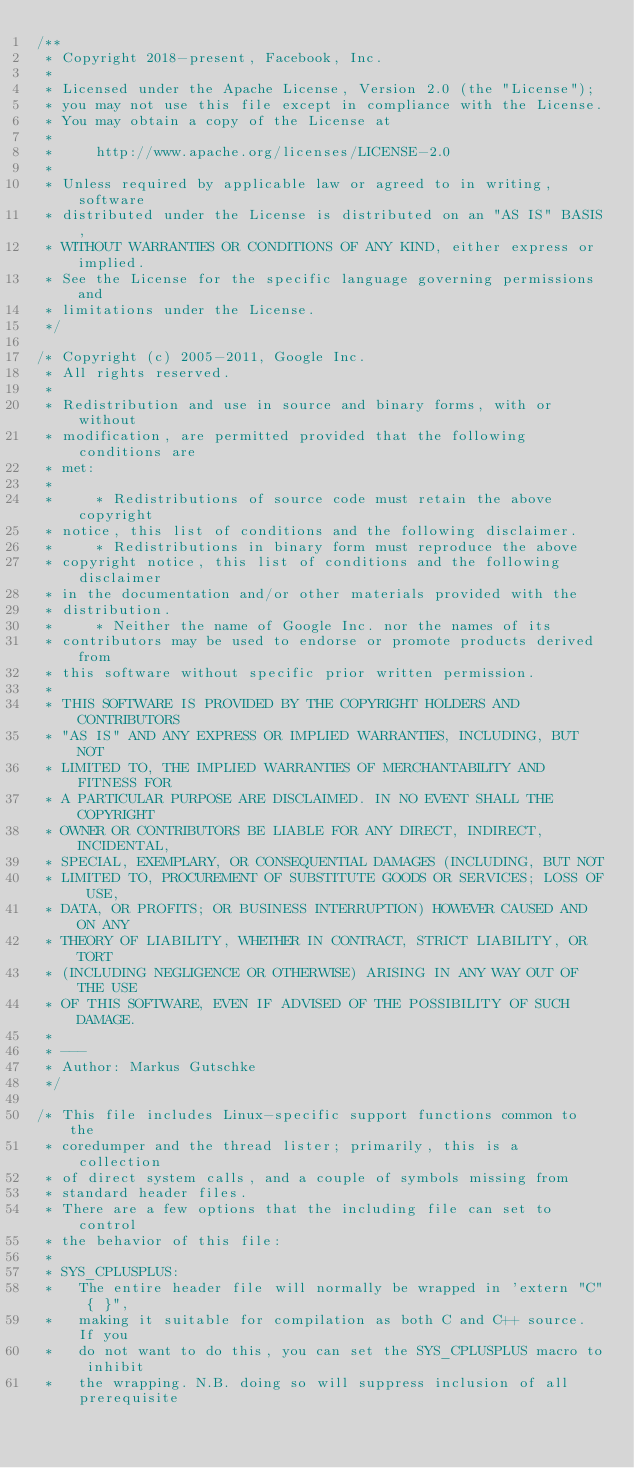Convert code to text. <code><loc_0><loc_0><loc_500><loc_500><_C_>/**
 * Copyright 2018-present, Facebook, Inc.
 *
 * Licensed under the Apache License, Version 2.0 (the "License");
 * you may not use this file except in compliance with the License.
 * You may obtain a copy of the License at
 *
 *     http://www.apache.org/licenses/LICENSE-2.0
 *
 * Unless required by applicable law or agreed to in writing, software
 * distributed under the License is distributed on an "AS IS" BASIS,
 * WITHOUT WARRANTIES OR CONDITIONS OF ANY KIND, either express or implied.
 * See the License for the specific language governing permissions and
 * limitations under the License.
 */

/* Copyright (c) 2005-2011, Google Inc.
 * All rights reserved.
 *
 * Redistribution and use in source and binary forms, with or without
 * modification, are permitted provided that the following conditions are
 * met:
 *
 *     * Redistributions of source code must retain the above copyright
 * notice, this list of conditions and the following disclaimer.
 *     * Redistributions in binary form must reproduce the above
 * copyright notice, this list of conditions and the following disclaimer
 * in the documentation and/or other materials provided with the
 * distribution.
 *     * Neither the name of Google Inc. nor the names of its
 * contributors may be used to endorse or promote products derived from
 * this software without specific prior written permission.
 *
 * THIS SOFTWARE IS PROVIDED BY THE COPYRIGHT HOLDERS AND CONTRIBUTORS
 * "AS IS" AND ANY EXPRESS OR IMPLIED WARRANTIES, INCLUDING, BUT NOT
 * LIMITED TO, THE IMPLIED WARRANTIES OF MERCHANTABILITY AND FITNESS FOR
 * A PARTICULAR PURPOSE ARE DISCLAIMED. IN NO EVENT SHALL THE COPYRIGHT
 * OWNER OR CONTRIBUTORS BE LIABLE FOR ANY DIRECT, INDIRECT, INCIDENTAL,
 * SPECIAL, EXEMPLARY, OR CONSEQUENTIAL DAMAGES (INCLUDING, BUT NOT
 * LIMITED TO, PROCUREMENT OF SUBSTITUTE GOODS OR SERVICES; LOSS OF USE,
 * DATA, OR PROFITS; OR BUSINESS INTERRUPTION) HOWEVER CAUSED AND ON ANY
 * THEORY OF LIABILITY, WHETHER IN CONTRACT, STRICT LIABILITY, OR TORT
 * (INCLUDING NEGLIGENCE OR OTHERWISE) ARISING IN ANY WAY OUT OF THE USE
 * OF THIS SOFTWARE, EVEN IF ADVISED OF THE POSSIBILITY OF SUCH DAMAGE.
 *
 * ---
 * Author: Markus Gutschke
 */

/* This file includes Linux-specific support functions common to the
 * coredumper and the thread lister; primarily, this is a collection
 * of direct system calls, and a couple of symbols missing from
 * standard header files.
 * There are a few options that the including file can set to control
 * the behavior of this file:
 *
 * SYS_CPLUSPLUS:
 *   The entire header file will normally be wrapped in 'extern "C" { }",
 *   making it suitable for compilation as both C and C++ source. If you
 *   do not want to do this, you can set the SYS_CPLUSPLUS macro to inhibit
 *   the wrapping. N.B. doing so will suppress inclusion of all prerequisite</code> 